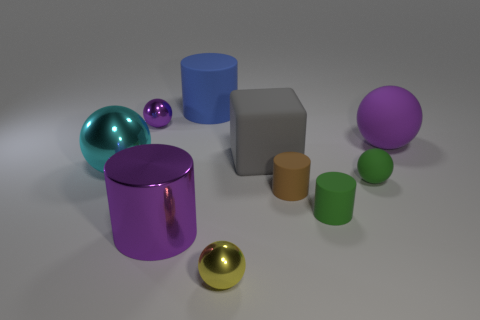There is a tiny thing that is in front of the brown rubber cylinder and left of the small brown cylinder; what color is it?
Your response must be concise. Yellow. What number of shiny balls have the same size as the purple metallic cylinder?
Make the answer very short. 1. The rubber object that is the same color as the shiny cylinder is what size?
Make the answer very short. Large. What is the size of the purple thing that is both behind the big purple metallic cylinder and right of the tiny purple shiny object?
Offer a very short reply. Large. There is a purple ball in front of the small ball that is on the left side of the blue rubber object; how many purple cylinders are behind it?
Provide a short and direct response. 0. Are there any tiny balls of the same color as the large metallic cylinder?
Offer a very short reply. Yes. What is the color of the other metal ball that is the same size as the yellow sphere?
Ensure brevity in your answer.  Purple. What is the shape of the metallic object that is on the right side of the blue rubber object left of the tiny metallic object in front of the big cyan object?
Give a very brief answer. Sphere. There is a large purple object left of the yellow object; what number of shiny spheres are behind it?
Give a very brief answer. 2. Is the shape of the tiny purple thing that is left of the tiny brown rubber object the same as the tiny green matte object behind the brown cylinder?
Offer a very short reply. Yes. 